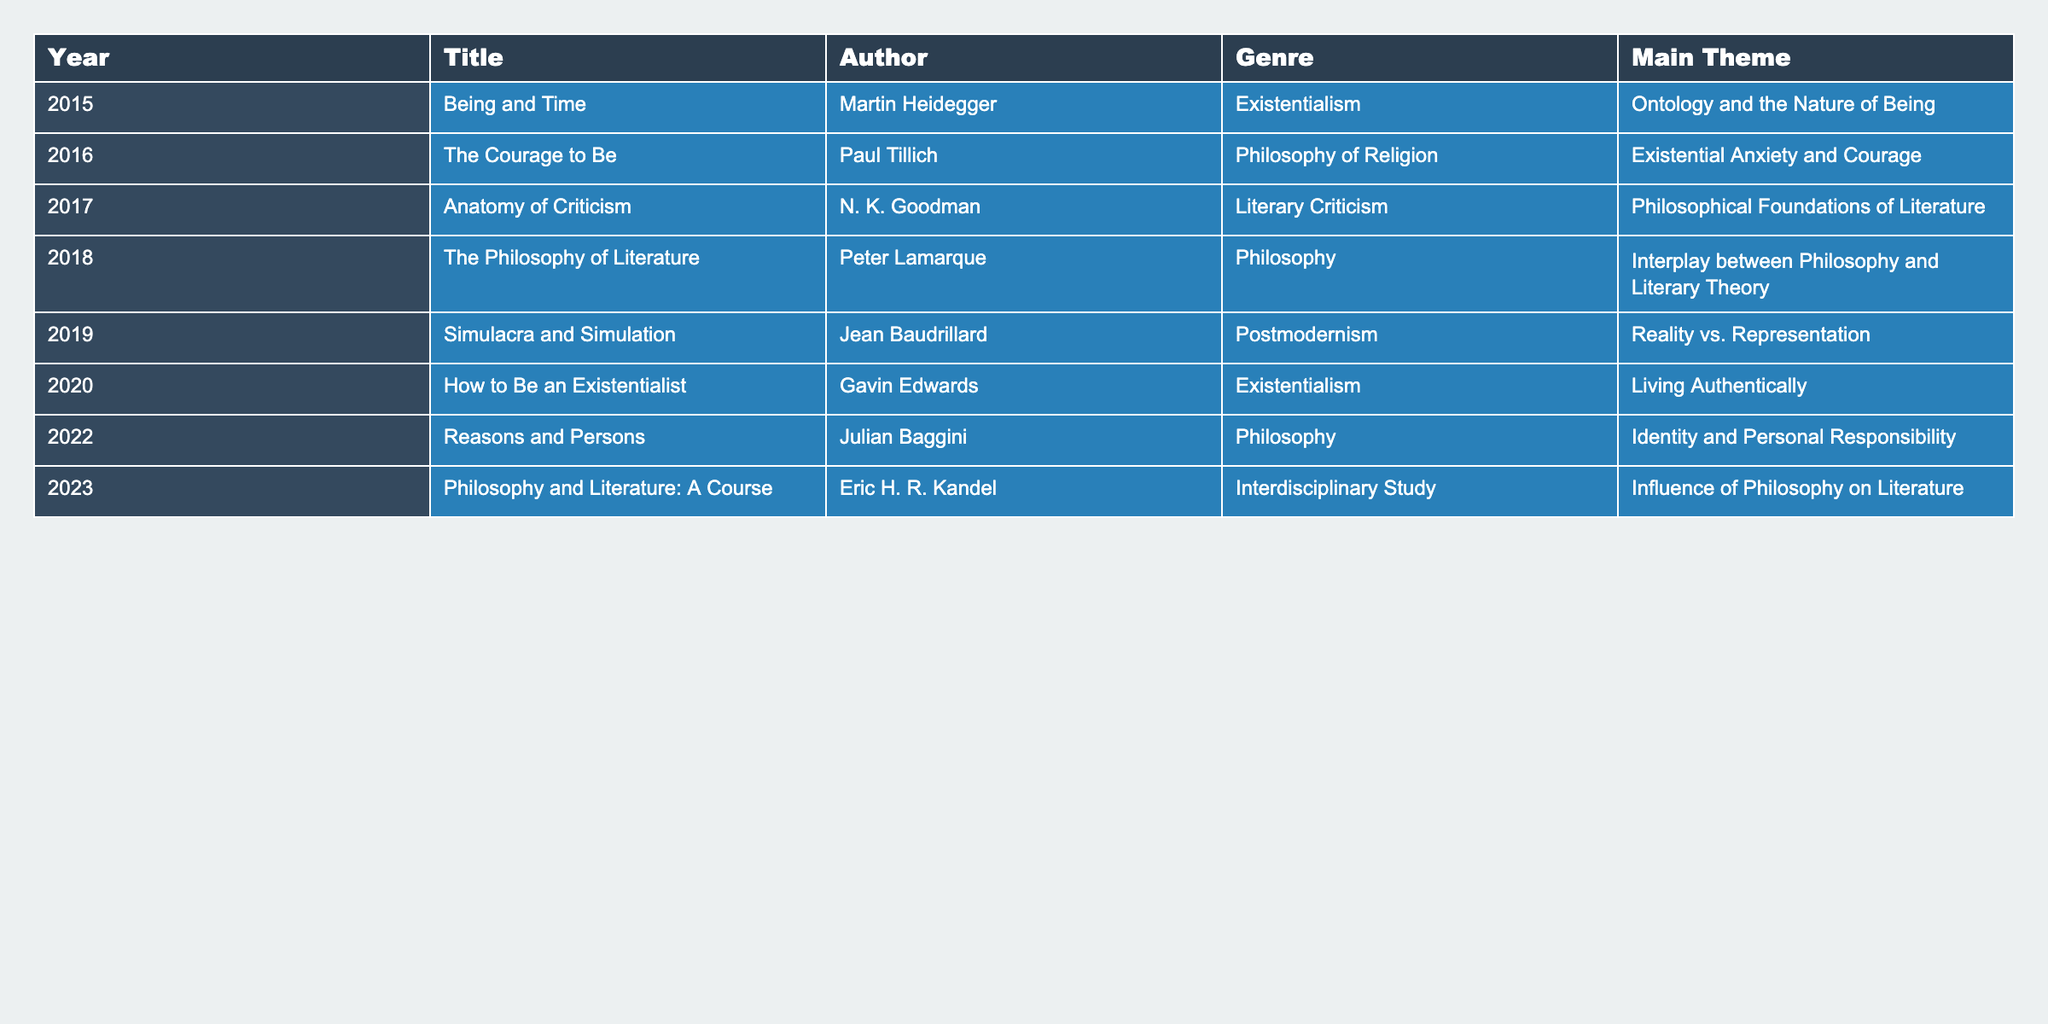What is the title of the book published in 2020? The table lists the titles by year, and for 2020, the title is found directly under that year. The entry in the table indicates that the title is "How to Be an Existentialist."
Answer: How to Be an Existentialist Who is the author of "Simulacra and Simulation"? By looking at the row for "Simulacra and Simulation" in the table, we can see that the author listed for this work is Jean Baudrillard.
Answer: Jean Baudrillard Which genre is most represented among the listed works? To identify the most represented genre, we count the occurrences of each genre presented in the table. The genres are Existentialism, Philosophy of Religion, Literary Criticism, Philosophy, Postmodernism, and Interdisciplinary Study. Counting them, we find that Existentialism appears three times.
Answer: Existentialism In what year was "Reasons and Persons" published? The table allows us to find the entry for "Reasons and Persons." Looking at the entry reveals that it was published in 2022.
Answer: 2022 Is "The Courage to Be" focused on the theme of identity? Checking the main theme associated with "The Courage to Be," we see that it is related to 'Existential Anxiety and Courage,' which does not focus on identity. Thus, the statement is false.
Answer: False Can you list the themes of the books published between 2016 and 2020? We review the entries for the years 2016 to 2020, which give the following themes: 2016 - 'Existential Anxiety and Courage', 2017 - 'Philosophical Foundations of Literature', 2018 - 'Interplay between Philosophy and Literary Theory', 2019 - 'Reality vs. Representation', and 2020 - 'Living Authentically'. Listing these gives us a complete set of themes for those years.
Answer: Existential Anxiety and Courage, Philosophical Foundations of Literature, Interplay between Philosophy and Literary Theory, Reality vs. Representation, Living Authentically What percentage of the works are categorized under 'Philosophy' as a genre? We first count the total number of works in the table, which is 8. Next, we determine how many of those works fall under the genre of 'Philosophy', which appears 3 times. We then calculate the percentage: (3/8) * 100 = 37.5%. Thus, we conclude the answer.
Answer: 37.5% Which author has multiple works in the table? By scanning through the author column of the table, we tally the occurrences of each author. Each author is unique in this list; hence, there are no authors with multiple works listed.
Answer: None 